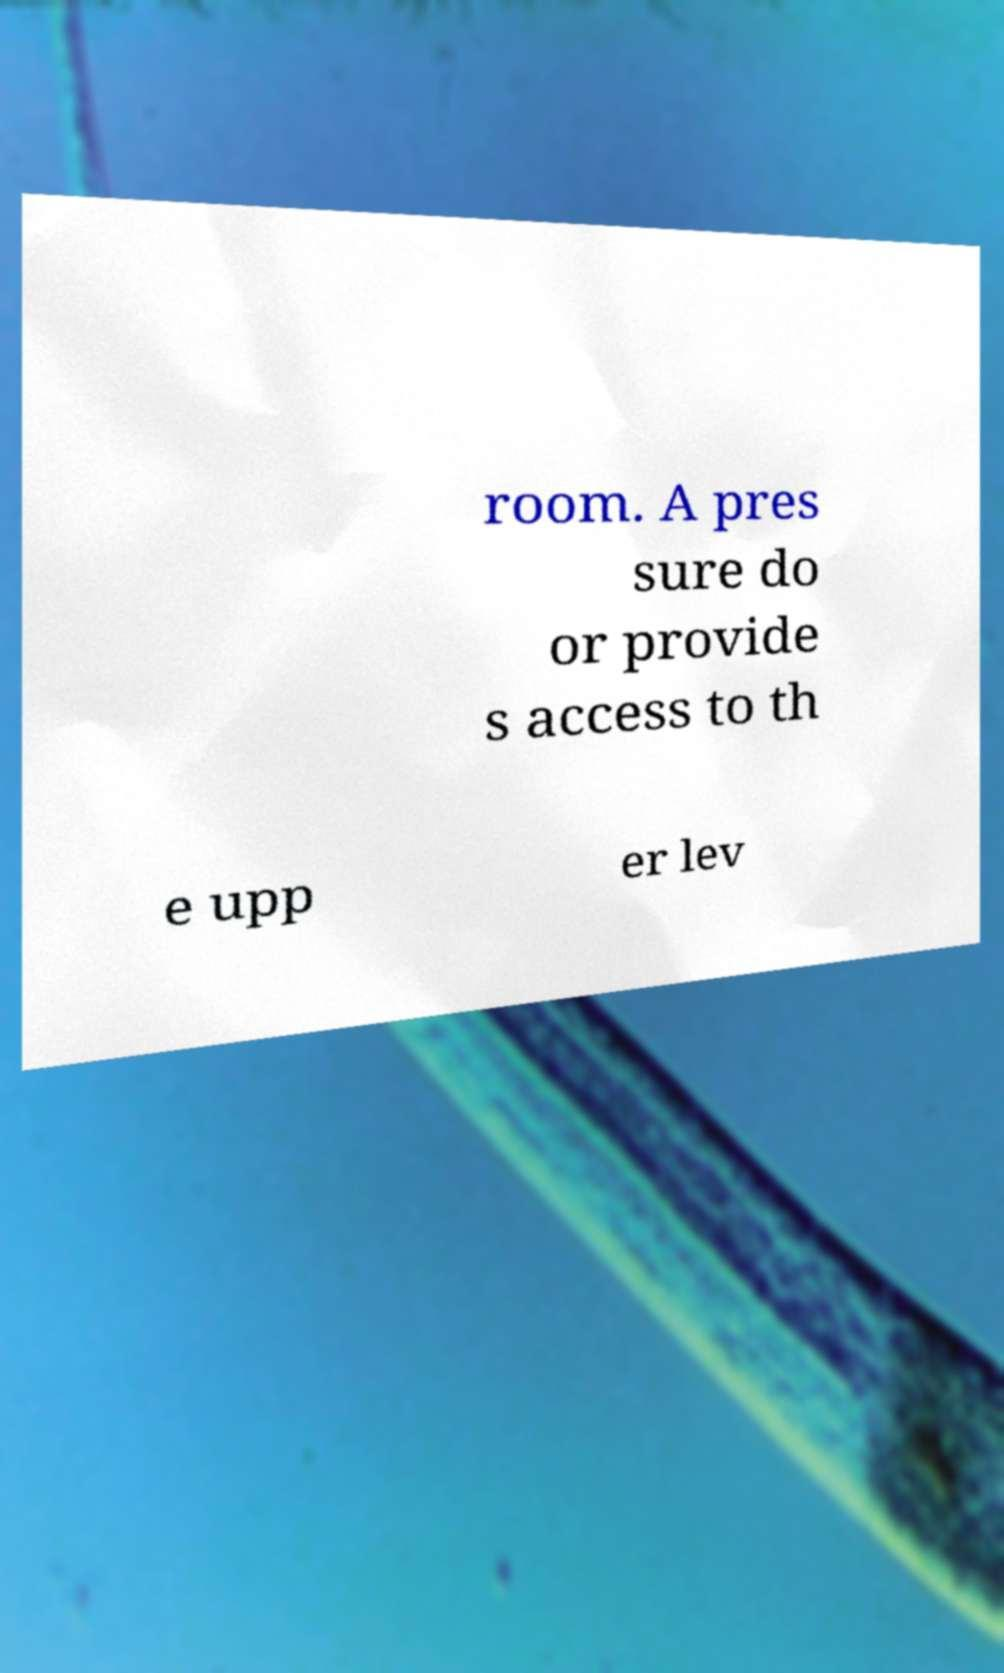Please identify and transcribe the text found in this image. room. A pres sure do or provide s access to th e upp er lev 